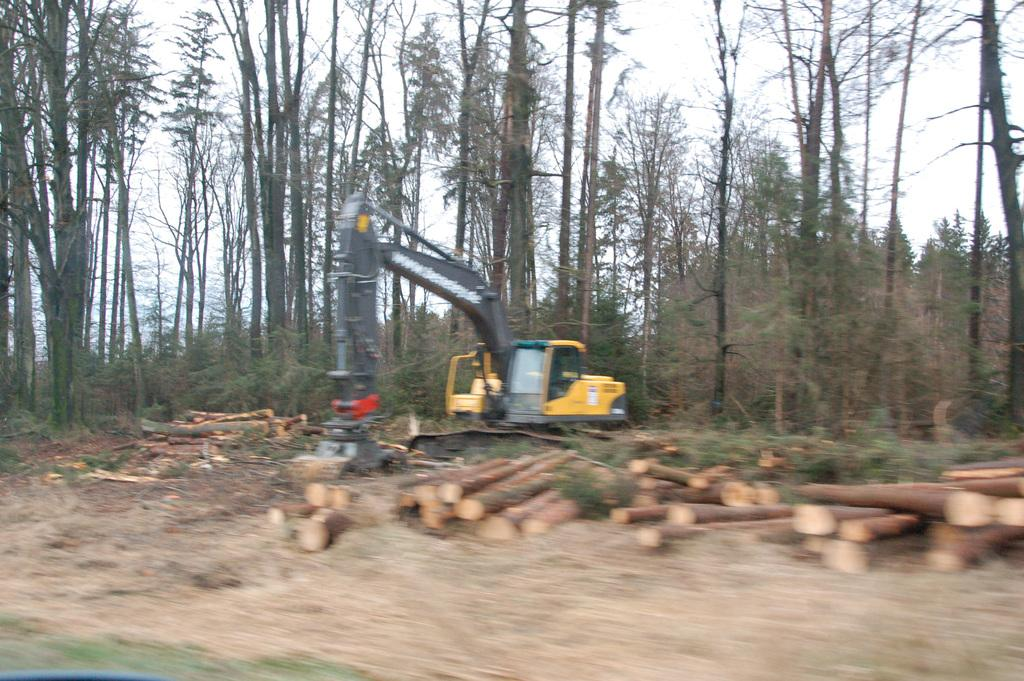What is on the ground in the image? There are wooden logs on the ground. What type of machinery can be seen in the image? There is an excavator in the image. What can be seen in the background of the image? There are many trees and the sky visible in the background. What science experiment is being conducted with the wooden logs in the image? There is no science experiment being conducted in the image; it simply shows wooden logs on the ground and an excavator. How much does the quarter cost in the image? There is no quarter present in the image, so it is not possible to determine its cost. 